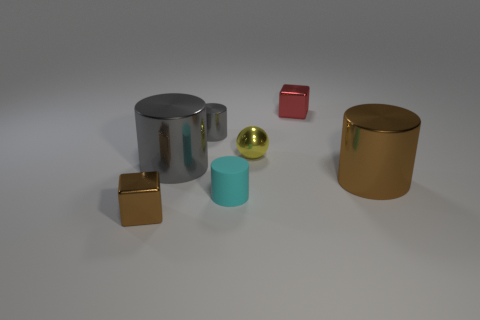Are there more gray things than small blue spheres?
Your answer should be very brief. Yes. There is a small red shiny object that is behind the small cyan object; is it the same shape as the yellow thing?
Make the answer very short. No. What number of rubber things are either balls or tiny cyan cylinders?
Your response must be concise. 1. Is there a big gray cylinder that has the same material as the small sphere?
Your answer should be very brief. Yes. What is the material of the small gray thing?
Keep it short and to the point. Metal. There is a large thing that is on the right side of the cube behind the cylinder that is on the right side of the cyan matte thing; what shape is it?
Keep it short and to the point. Cylinder. Are there more tiny red shiny cubes left of the small cyan rubber thing than gray things?
Offer a terse response. No. There is a tiny cyan thing; is it the same shape as the brown shiny thing behind the cyan matte object?
Your response must be concise. Yes. There is a big shiny object that is the same color as the small metal cylinder; what shape is it?
Offer a very short reply. Cylinder. What number of yellow balls are to the right of the metal cube behind the gray shiny object behind the tiny metal sphere?
Keep it short and to the point. 0. 